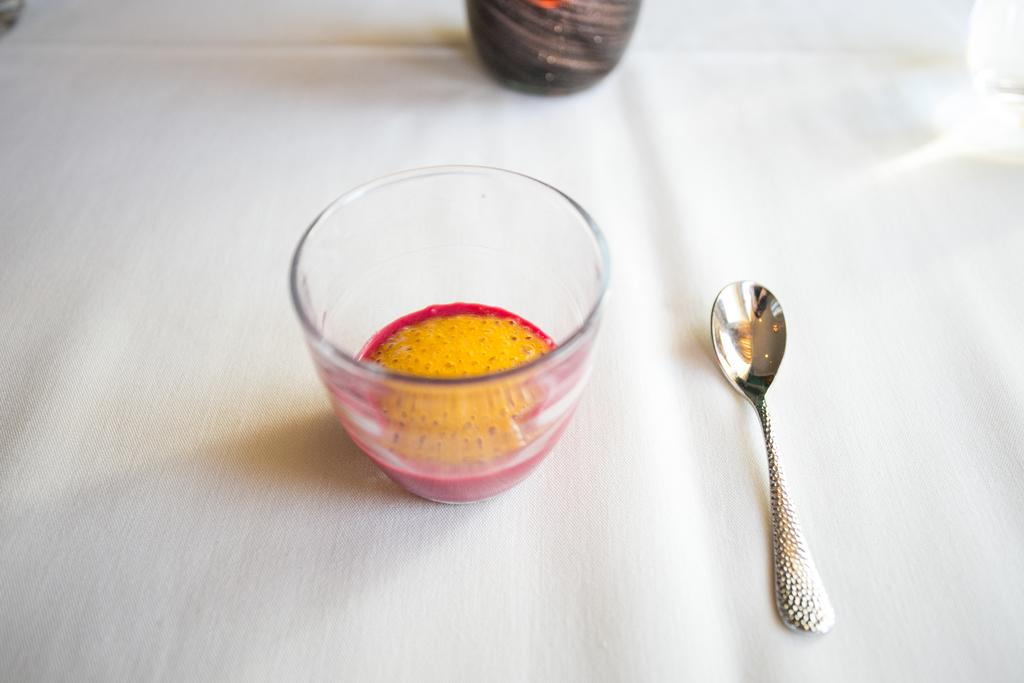What is located on the table in the image? There is a bowl and a spoon on the table in the image. What is the color in the bowl? The color in the bowl suggests that there is something colorful inside the bowl. What might be used to eat or scoop the contents of the bowl? The spoon in the image might be used to eat or scoop the contents of the bowl. What type of frame is surrounding the bowl in the image? There is no frame surrounding the bowl in the image. Is there a light source visible in the image? There is no light source visible in the image. Can you see a cow in the image? There is no cow present in the image. 